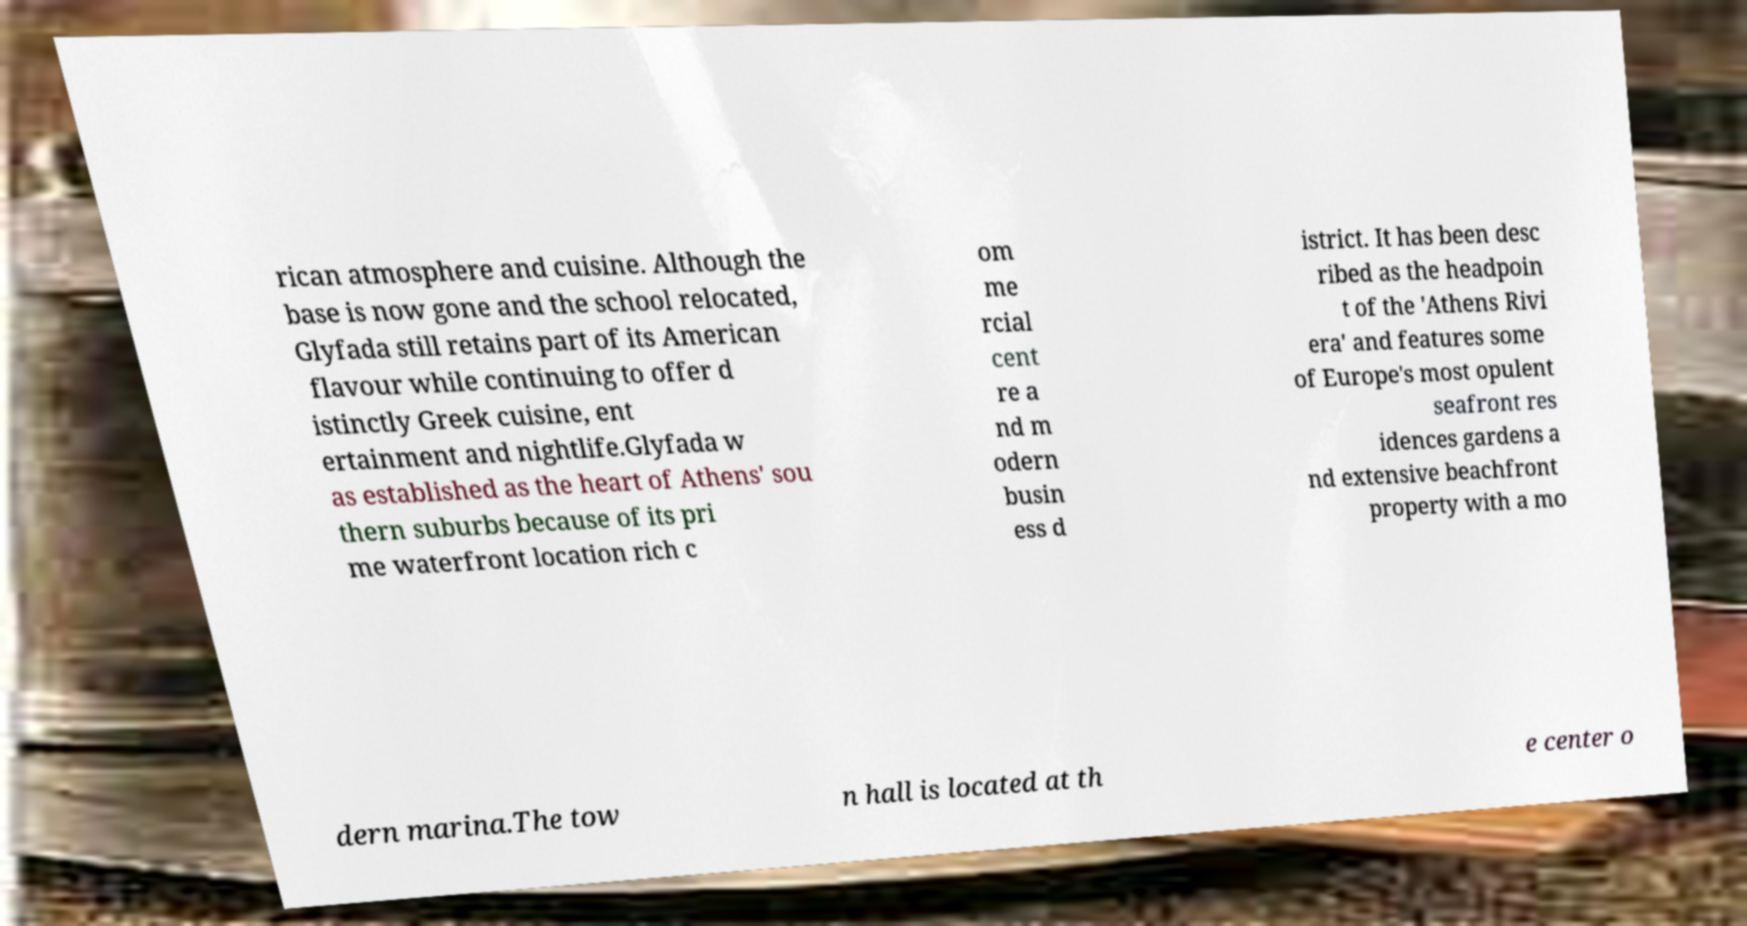Please read and relay the text visible in this image. What does it say? rican atmosphere and cuisine. Although the base is now gone and the school relocated, Glyfada still retains part of its American flavour while continuing to offer d istinctly Greek cuisine, ent ertainment and nightlife.Glyfada w as established as the heart of Athens' sou thern suburbs because of its pri me waterfront location rich c om me rcial cent re a nd m odern busin ess d istrict. It has been desc ribed as the headpoin t of the 'Athens Rivi era' and features some of Europe's most opulent seafront res idences gardens a nd extensive beachfront property with a mo dern marina.The tow n hall is located at th e center o 